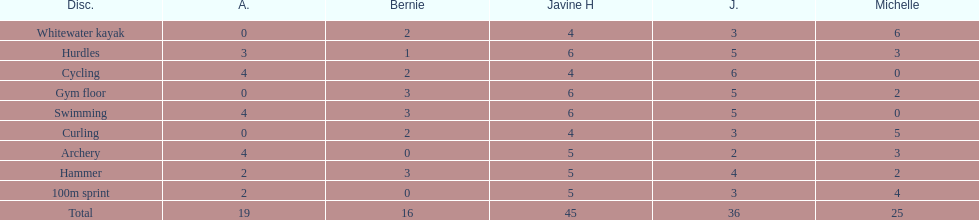Who is the quickest runner? Javine H. 